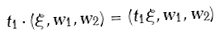<formula> <loc_0><loc_0><loc_500><loc_500>t _ { 1 } \cdot ( \xi , w _ { 1 } , w _ { 2 } ) = ( t _ { 1 } \xi , w _ { 1 } , w _ { 2 } )</formula> 